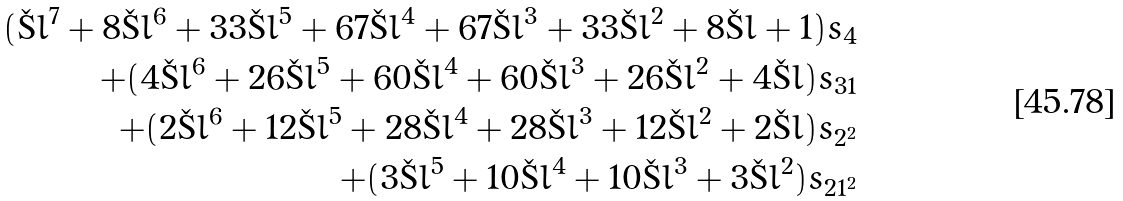Convert formula to latex. <formula><loc_0><loc_0><loc_500><loc_500>( \L l ^ { 7 } + 8 \L l ^ { 6 } + 3 3 \L l ^ { 5 } + 6 7 \L l ^ { 4 } + 6 7 \L l ^ { 3 } + 3 3 \L l ^ { 2 } + 8 \L l + 1 ) s _ { 4 } \\ + ( 4 \L l ^ { 6 } + 2 6 \L l ^ { 5 } + 6 0 \L l ^ { 4 } + 6 0 \L l ^ { 3 } + 2 6 \L l ^ { 2 } + 4 \L l ) s _ { 3 1 } \\ + ( 2 \L l ^ { 6 } + 1 2 \L l ^ { 5 } + 2 8 \L l ^ { 4 } + 2 8 \L l ^ { 3 } + 1 2 \L l ^ { 2 } + 2 \L l ) s _ { 2 ^ { 2 } } \\ + ( 3 \L l ^ { 5 } + 1 0 \L l ^ { 4 } + 1 0 \L l ^ { 3 } + 3 \L l ^ { 2 } ) s _ { 2 1 ^ { 2 } }</formula> 